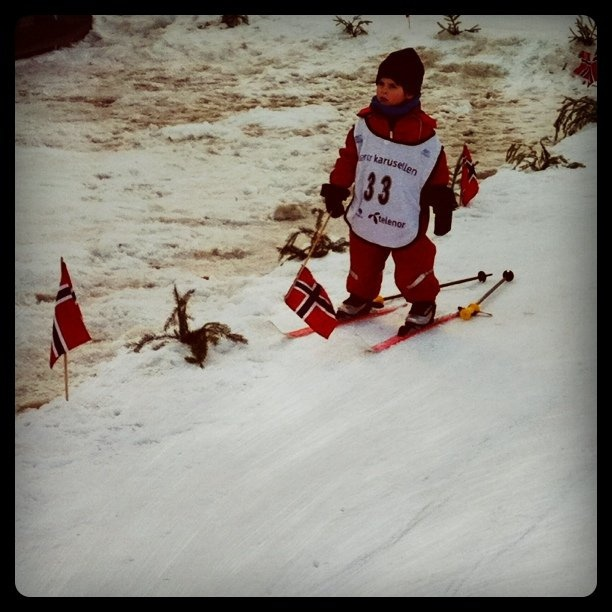Describe the objects in this image and their specific colors. I can see people in black, maroon, and gray tones and skis in black, brown, maroon, and darkgray tones in this image. 